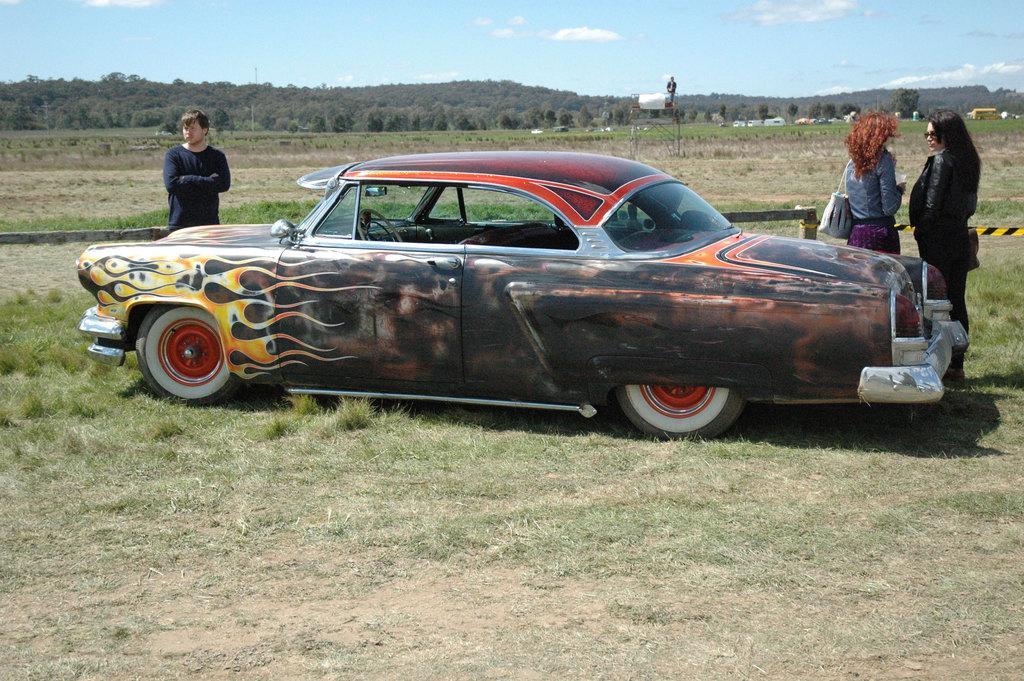In one or two sentences, can you explain what this image depicts? In this picture there is a classic car parked in the ground. On the left side there is a man wearing black color full sleeve t-shirt standing and looking on the left. On the right corner there are two women talking with each other. Behind we can see the hill full of trees. 